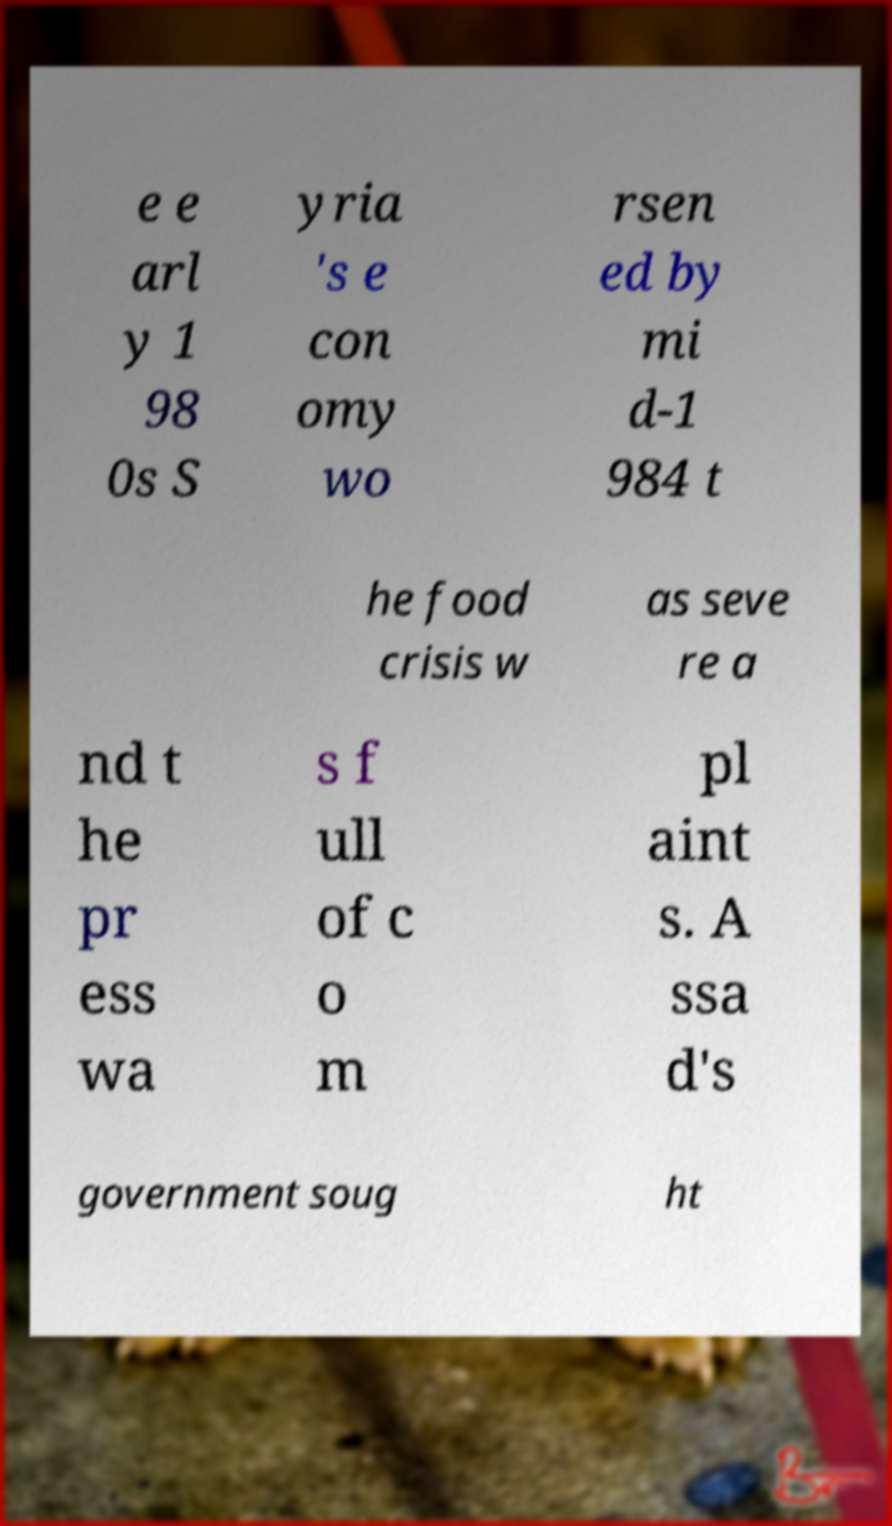Could you extract and type out the text from this image? e e arl y 1 98 0s S yria 's e con omy wo rsen ed by mi d-1 984 t he food crisis w as seve re a nd t he pr ess wa s f ull of c o m pl aint s. A ssa d's government soug ht 